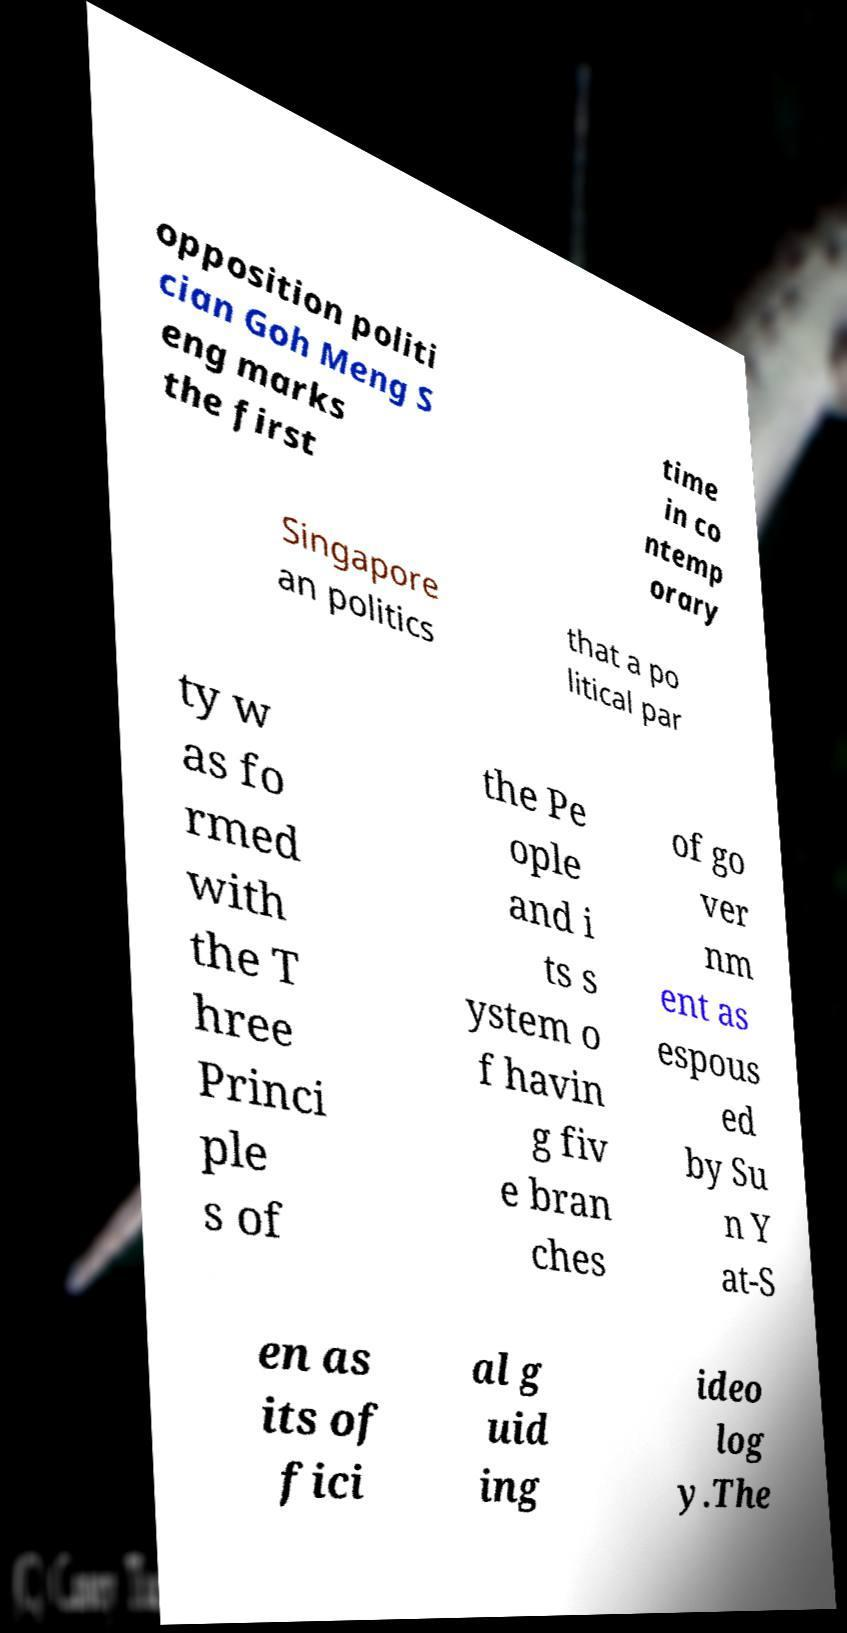Can you accurately transcribe the text from the provided image for me? opposition politi cian Goh Meng S eng marks the first time in co ntemp orary Singapore an politics that a po litical par ty w as fo rmed with the T hree Princi ple s of the Pe ople and i ts s ystem o f havin g fiv e bran ches of go ver nm ent as espous ed by Su n Y at-S en as its of fici al g uid ing ideo log y.The 